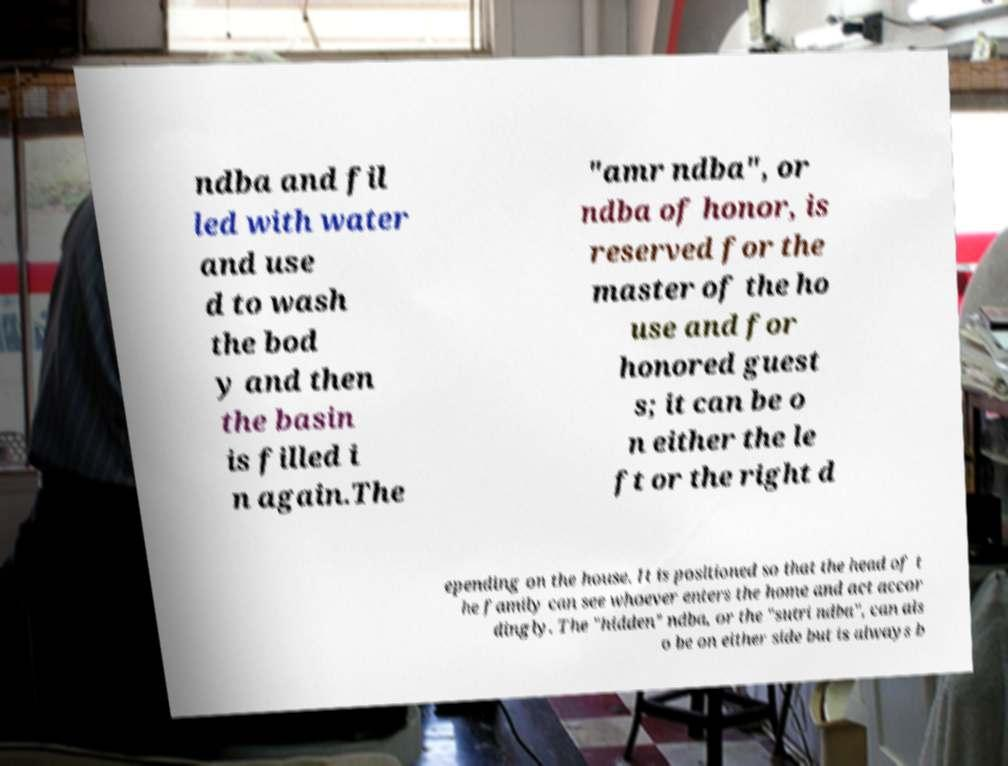Could you extract and type out the text from this image? ndba and fil led with water and use d to wash the bod y and then the basin is filled i n again.The "amr ndba", or ndba of honor, is reserved for the master of the ho use and for honored guest s; it can be o n either the le ft or the right d epending on the house. It is positioned so that the head of t he family can see whoever enters the home and act accor dingly. The "hidden" ndba, or the "sutri ndba", can als o be on either side but is always b 